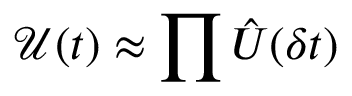Convert formula to latex. <formula><loc_0><loc_0><loc_500><loc_500>\mathcal { U } ( t ) \approx \prod \hat { U } ( \delta t )</formula> 